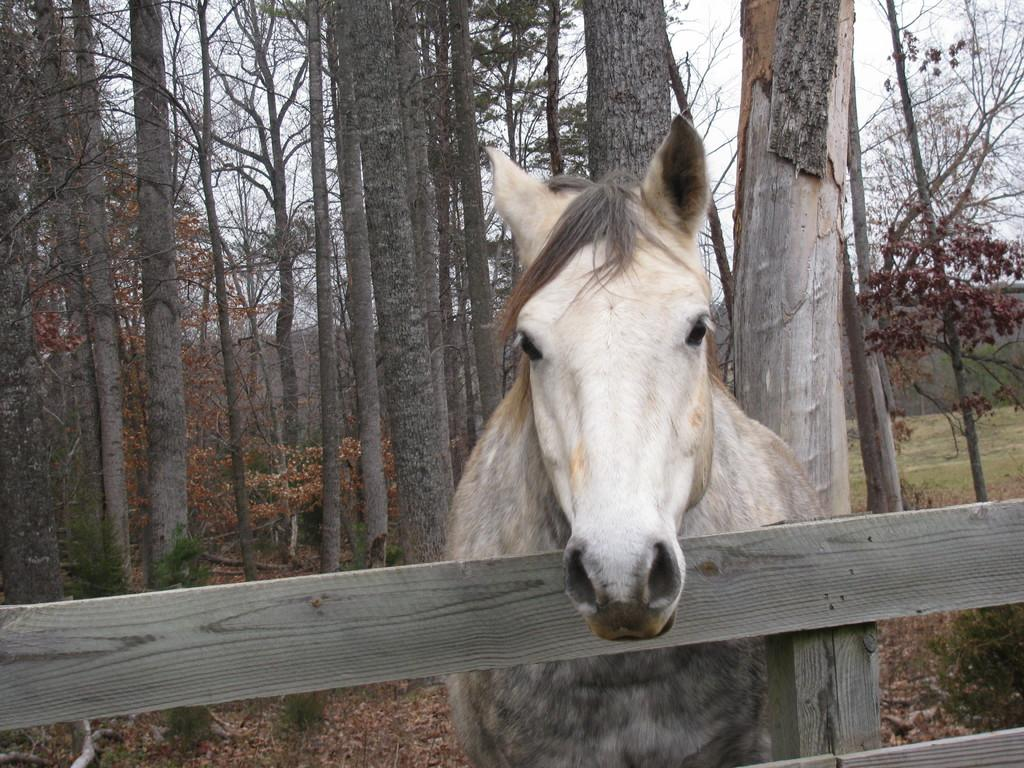What type of fencing is present in the image? There is a wooden fencing with a pole in the image. What animal is near the wooden fencing? There is a horse near the wooden fencing. What can be seen in the background of the image? There are trees and the sky visible in the background of the image. How many ducks are visible in the image? There are no ducks present in the image; it features a wooden fencing with a pole and a horse. What type of pail is being used by the horse in the image? There is no pail present in the image, and the horse is not using any object. 